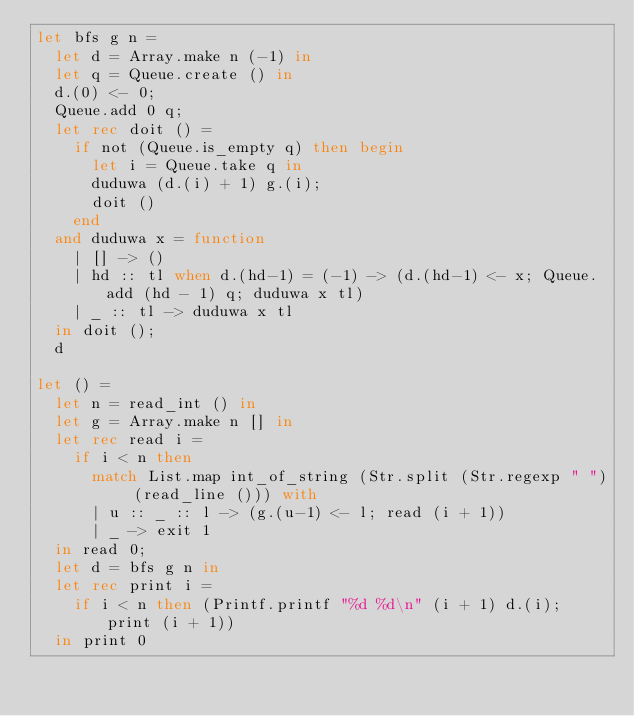Convert code to text. <code><loc_0><loc_0><loc_500><loc_500><_OCaml_>let bfs g n =
  let d = Array.make n (-1) in
  let q = Queue.create () in
  d.(0) <- 0;
  Queue.add 0 q;
  let rec doit () =
    if not (Queue.is_empty q) then begin
      let i = Queue.take q in
      duduwa (d.(i) + 1) g.(i);
      doit ()
    end
  and duduwa x = function
    | [] -> ()
    | hd :: tl when d.(hd-1) = (-1) -> (d.(hd-1) <- x; Queue.add (hd - 1) q; duduwa x tl)
    | _ :: tl -> duduwa x tl
  in doit ();
  d

let () =
  let n = read_int () in
  let g = Array.make n [] in
  let rec read i =
    if i < n then
      match List.map int_of_string (Str.split (Str.regexp " ") (read_line ())) with
      | u :: _ :: l -> (g.(u-1) <- l; read (i + 1))
      | _ -> exit 1
  in read 0;
  let d = bfs g n in
  let rec print i =
    if i < n then (Printf.printf "%d %d\n" (i + 1) d.(i); print (i + 1))
  in print 0</code> 